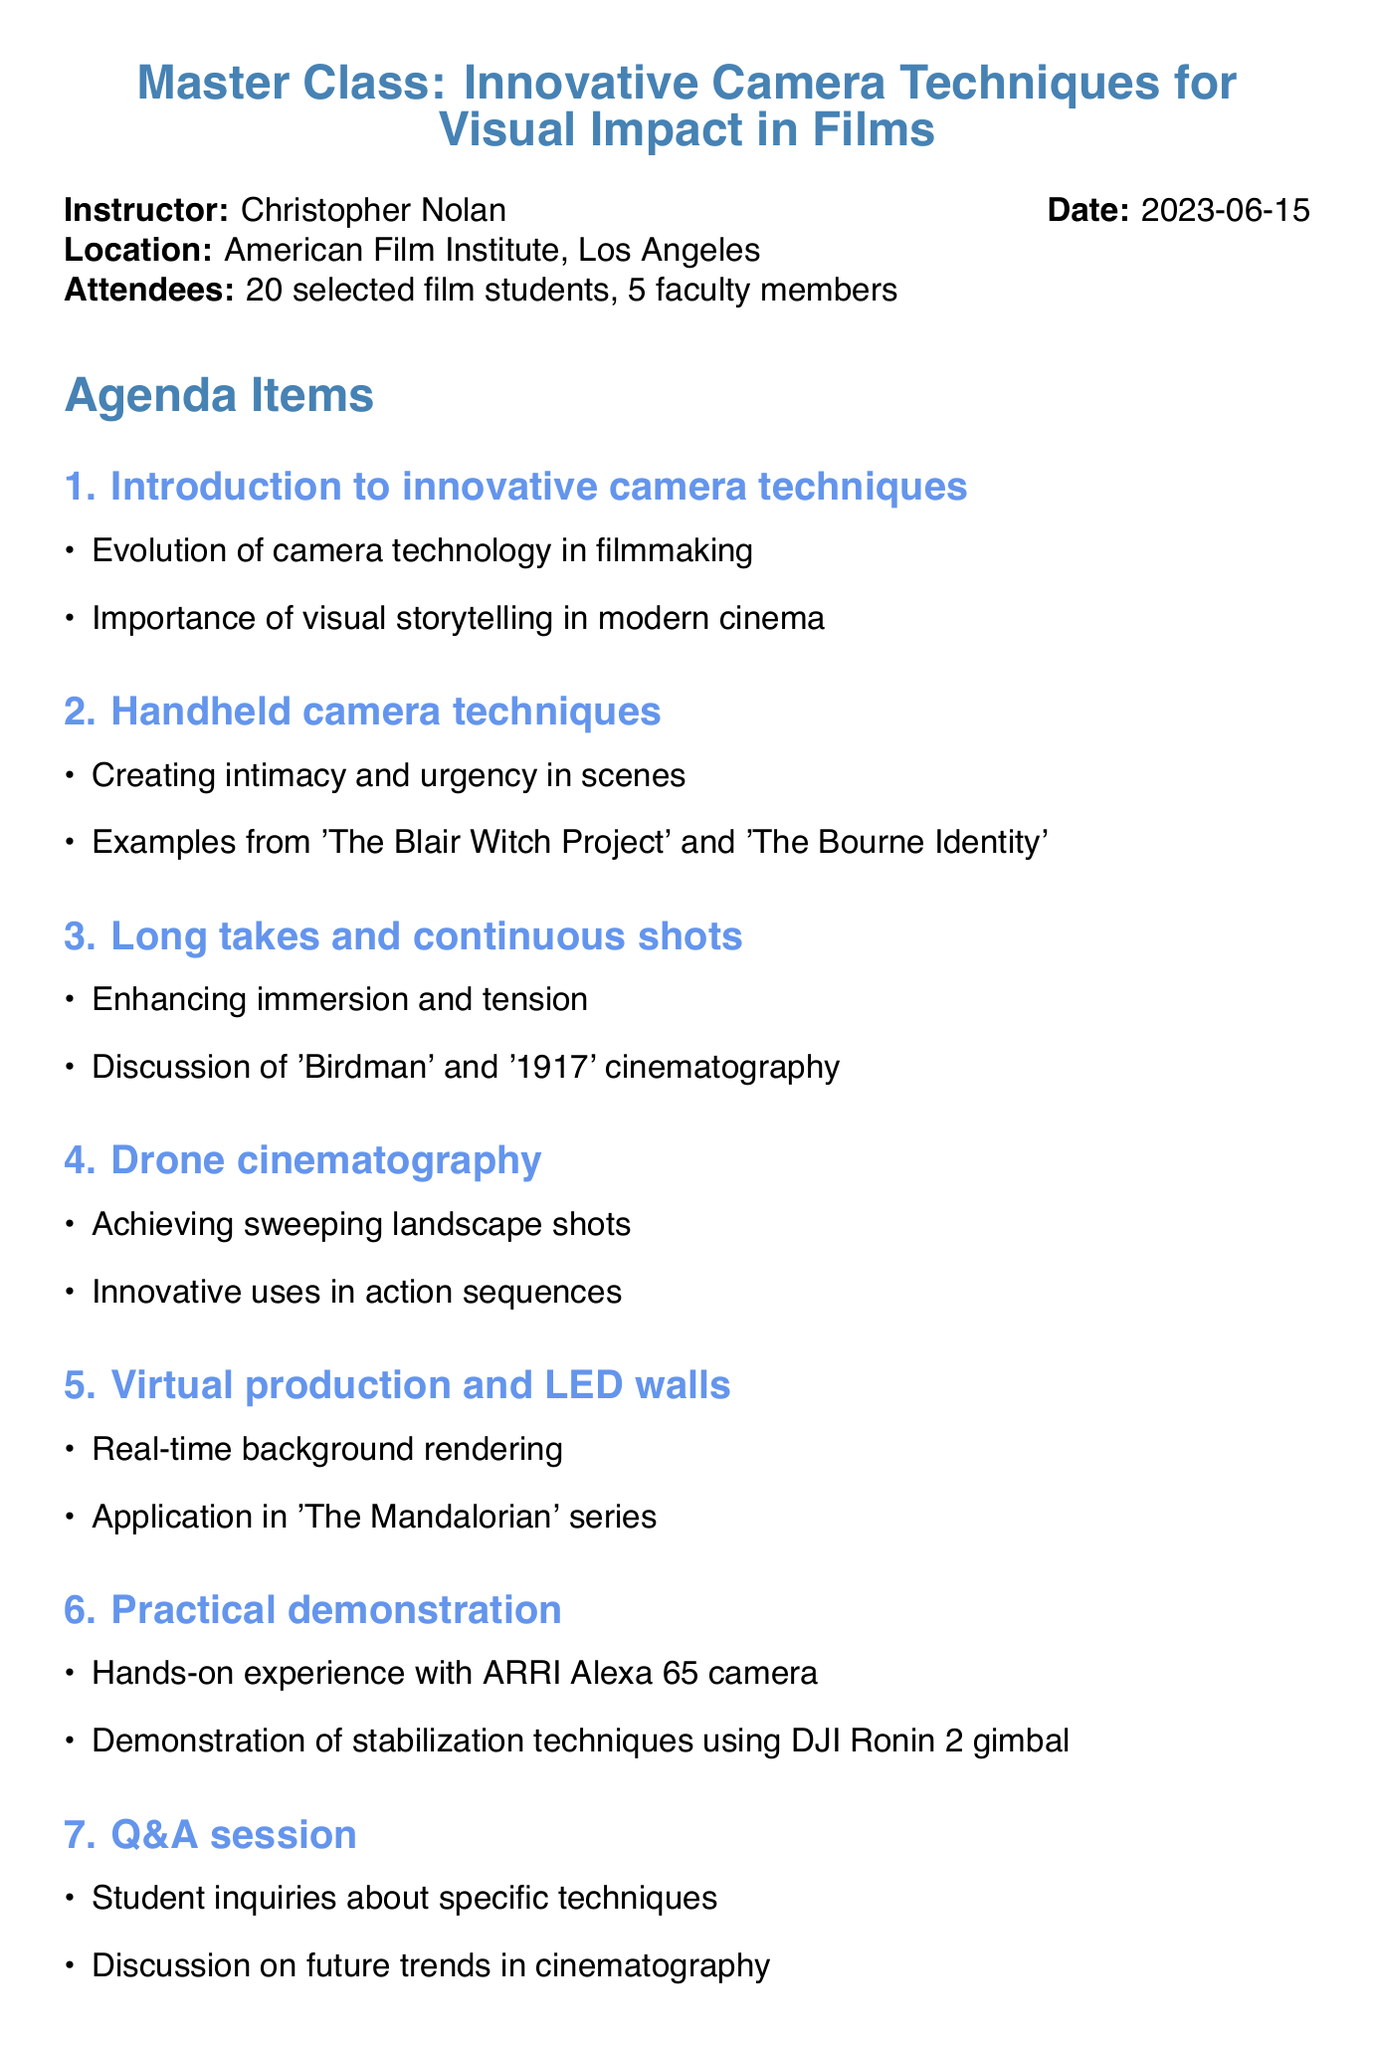what is the title of the meeting? The title of the meeting is the focal point of the document, highlighting the subject of the discussion.
Answer: Master Class: Innovative Camera Techniques for Visual Impact in Films who is the instructor? The document specifies the person leading the master class.
Answer: Christopher Nolan when was the meeting held? The date of the meeting is crucial for context regarding the timing of the discussion.
Answer: 2023-06-15 where did the meeting take place? The location provides context about where the event occurred.
Answer: American Film Institute, Los Angeles how many film students attended? The number of attendees can showcase the size of the class.
Answer: 20 selected film students what was one topic discussed in the agenda? This question probes into the various subjects highlighted during the meeting.
Answer: Introduction to innovative camera techniques what is one action item from the meeting? The action items indicate follow-up tasks resulting from the discussions held.
Answer: Students to submit a short film showcasing at least one innovative camera technique what unique technology was discussed in relation to 'The Mandalorian'? This question targets specific examples mentioned in the document, requiring recall of details from it.
Answer: LED walls what type of camera was used for practical demonstrations? This question focuses on the equipment discussed as part of the practical applications explored during the meeting.
Answer: ARRI Alexa 65 camera 